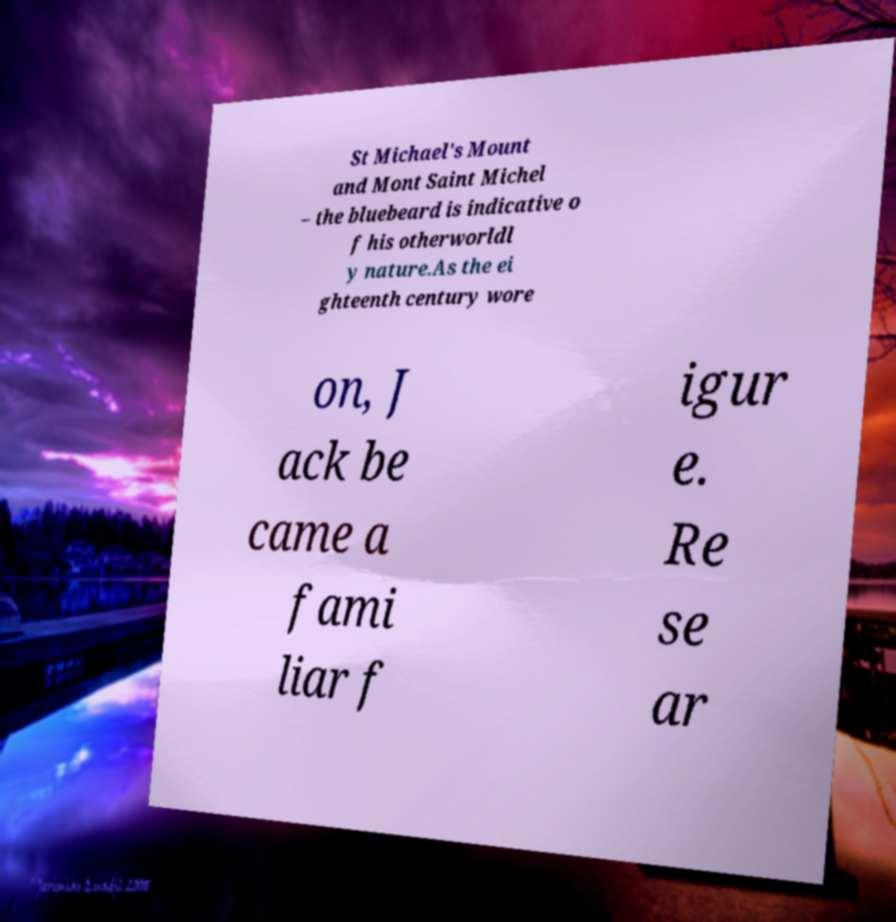What messages or text are displayed in this image? I need them in a readable, typed format. St Michael's Mount and Mont Saint Michel – the bluebeard is indicative o f his otherworldl y nature.As the ei ghteenth century wore on, J ack be came a fami liar f igur e. Re se ar 